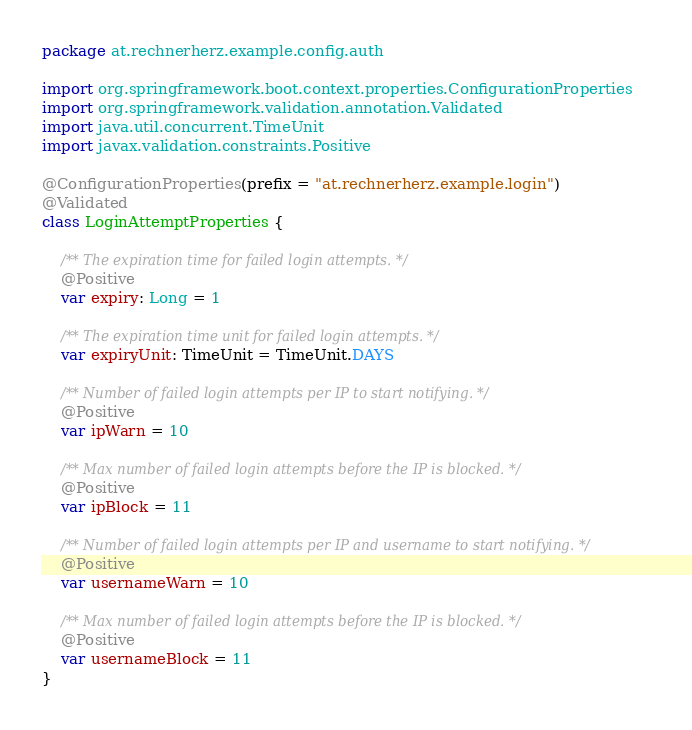Convert code to text. <code><loc_0><loc_0><loc_500><loc_500><_Kotlin_>package at.rechnerherz.example.config.auth

import org.springframework.boot.context.properties.ConfigurationProperties
import org.springframework.validation.annotation.Validated
import java.util.concurrent.TimeUnit
import javax.validation.constraints.Positive

@ConfigurationProperties(prefix = "at.rechnerherz.example.login")
@Validated
class LoginAttemptProperties {

    /** The expiration time for failed login attempts. */
    @Positive
    var expiry: Long = 1

    /** The expiration time unit for failed login attempts. */
    var expiryUnit: TimeUnit = TimeUnit.DAYS

    /** Number of failed login attempts per IP to start notifying. */
    @Positive
    var ipWarn = 10

    /** Max number of failed login attempts before the IP is blocked. */
    @Positive
    var ipBlock = 11

    /** Number of failed login attempts per IP and username to start notifying. */
    @Positive
    var usernameWarn = 10

    /** Max number of failed login attempts before the IP is blocked. */
    @Positive
    var usernameBlock = 11
}
</code> 